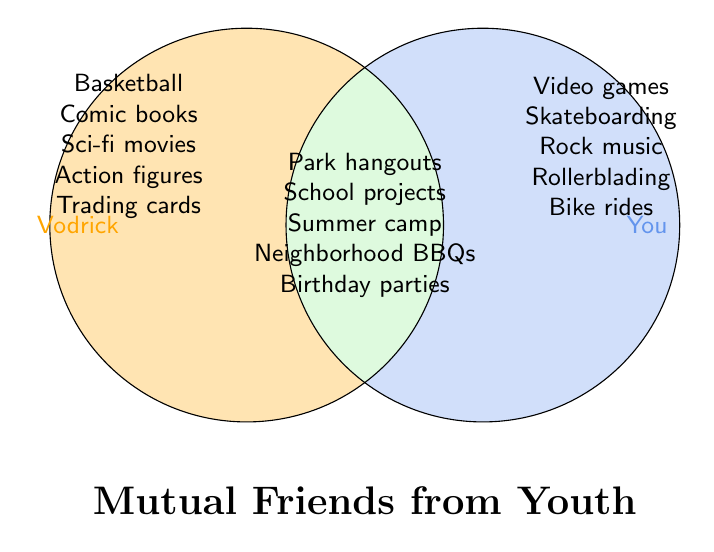What activities are common between Vodrick and you? The activities located in the overlapping area of the Venn Diagram represent mutual activities. These are: Park hangouts, School projects, Summer camp, Neighborhood BBQs, and Birthday parties
Answer: Park hangouts, School projects, Summer camp, Neighborhood BBQs, Birthday parties Which activities are unique to you? Activities unique to you are located in the right part of the Venn Diagram that does not overlap with Vodrick's area. These are: Video games, Skateboarding, Rock music, Rollerblading, and Bike rides
Answer: Video games, Skateboarding, Rock music, Rollerblading, Bike rides How many more unique activities does Vodrick have compared to you? First, count activities unique to Vodrick: Basketball, Comic books, Sci-fi movies, Action figures, Trading cards (5 activities). Next, count activities unique to you: Video games, Skateboarding, Rock music, Rollerblading, Bike rides (5 activities). Subtract the number of your unique activities from Vodrick’s unique activities: 5 - 5 = 0
Answer: 0 Which mutual activity falls under both Vodrick and you, is not found in either separate list? Mutual activities fall in the overlapping area: Park hangouts, School projects, Summer camp, Neighborhood BBQs, and Birthday parties. Check if these are not in Vodrick's or your unique list: none of them are.
Answer: None of them are found in either list What are the color representations of the different segments in the diagram? The Venn diagram uses different colors for different segments. The left circle representing Vodrick's activities is filled with a light orange. The right circle representing your activities is filled with light blue. The overlapping area representing mutual activities is filled with light green.
Answer: Light orange for Vodrick, Light blue for you, Light green for both 